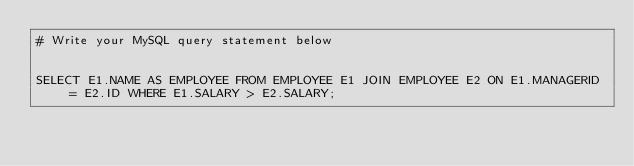<code> <loc_0><loc_0><loc_500><loc_500><_SQL_># Write your MySQL query statement below


SELECT E1.NAME AS EMPLOYEE FROM EMPLOYEE E1 JOIN EMPLOYEE E2 ON E1.MANAGERID = E2.ID WHERE E1.SALARY > E2.SALARY;</code> 